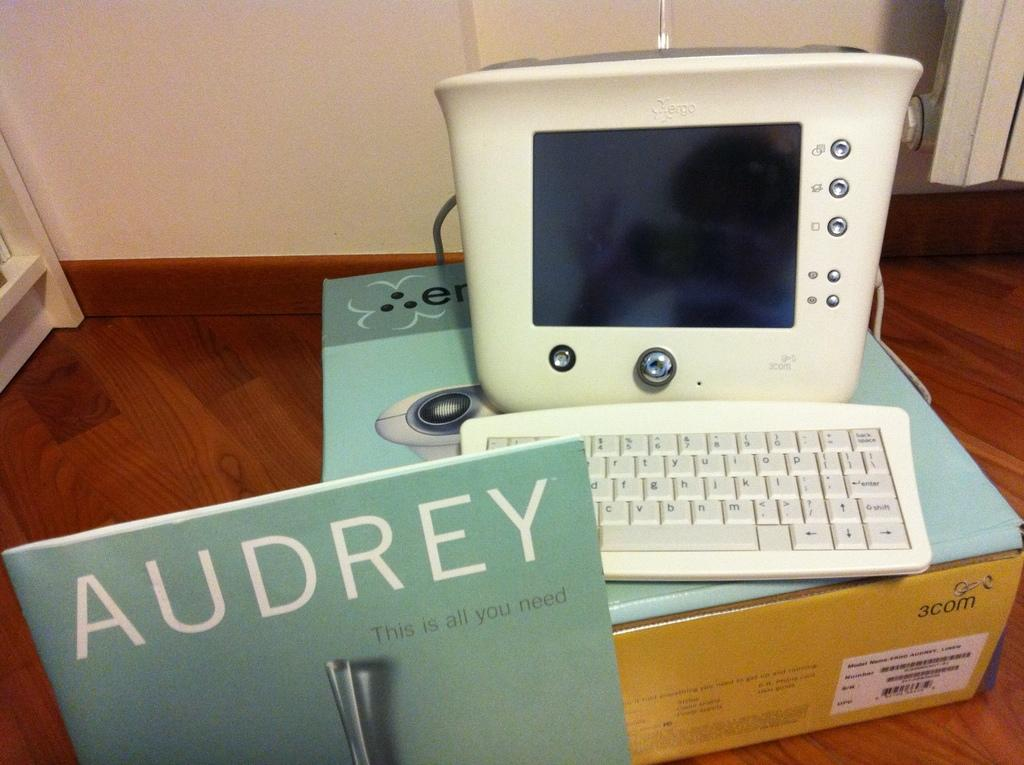<image>
Present a compact description of the photo's key features. A computer with a 1970's design sits behind a pamphlet with the name Audrey on it. 